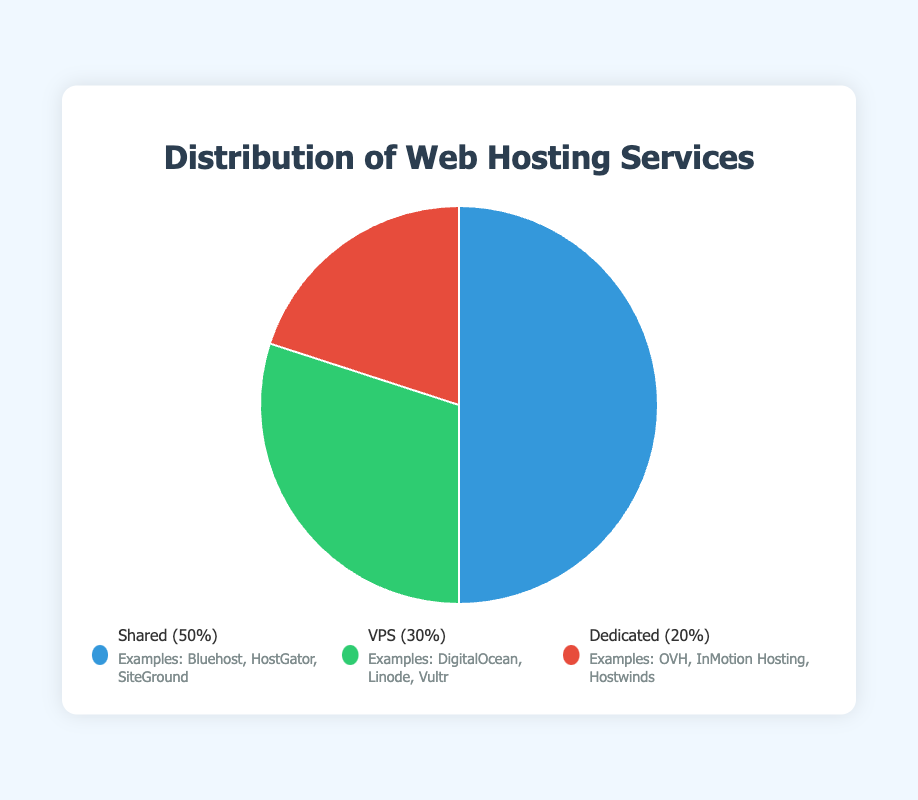How much more popular is Shared hosting compared to Dedicated hosting? Shared hosting has a percentage of 50%, and Dedicated hosting has 20%. The difference is 50% - 20% = 30%.
Answer: 30% Which type of hosting service is the most popular? The pie chart shows that Shared hosting has the highest percentage at 50%, making it the most popular.
Answer: Shared Rank the hosting types from most popular to least popular. The percentages are Shared (50%), VPS (30%), and Dedicated (20%). Therefore, the ranking from most to least popular is Shared, VPS, Dedicated.
Answer: Shared, VPS, Dedicated What is the combined percentage of Shared and VPS hosting? The percentage of Shared hosting is 50%, and VPS hosting is 30%. Adding them together gives 50% + 30% = 80%.
Answer: 80% Which color represents VPS hosting in the chart? VPS hosting is represented by the green section of the pie chart.
Answer: Green What percentage of the web hosting market is not represented by VPS hosting? The percentage of VPS hosting is 30%, so the remaining market percentage is 100% - 30% = 70%.
Answer: 70% What are some examples of Dedicated hosting services? According to the legend, examples of Dedicated hosting services are OVH, InMotion Hosting, and Hostwinds.
Answer: OVH, InMotion Hosting, Hostwinds If another hosting type was included in the pie chart with a 10% share, what would be the new percentage of Shared hosting? The current percentage of Shared hosting is 50%. If another type takes 10%, the remaining 90% would still need to be allocated to the current types proportionally. Shared hosting would then be (50% of 90%) = 0.50 * 90% = 45%.
Answer: 45% 